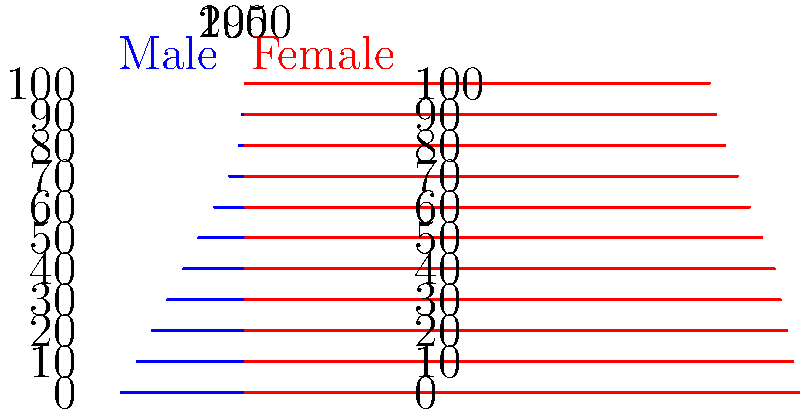Based on the population pyramids shown for 1950 and 2000, which demographic trend is most evident, and how might this impact the social and economic aspects discussed in the historian's book? To answer this question, let's analyze the population pyramids step-by-step:

1. Shape comparison:
   - 1950 pyramid: Wide base, narrow top (triangular shape)
   - 2000 pyramid: More rectangular shape, with a slightly narrower base

2. Age distribution:
   - 1950: Larger proportion of younger population (wider base)
   - 2000: More evenly distributed across age groups

3. Elderly population:
   - 1950: Very small proportion at the top of the pyramid
   - 2000: Larger proportion at the top, indicating increased longevity

4. Working-age population:
   - 1950: Smaller proportion in the middle
   - 2000: Larger proportion in the middle-age groups

5. Main trend: Aging population
   The most evident demographic trend is the aging of the population, as seen by the shift from a triangular shape to a more rectangular one.

6. Potential impacts discussed in the book:
   a. Social aspects:
      - Increased demand for healthcare and elderly care services
      - Changes in family structures and intergenerational relationships
      - Potential shifts in social norms and values

   b. Economic aspects:
      - Pressure on pension systems and social security
      - Changes in the labor force composition
      - Potential impact on economic growth and productivity
      - Shifts in consumer markets and product demands

   c. Policy implications:
      - Need for healthcare reform
      - Retirement age adjustments
      - Immigration policies to address workforce needs

The historian's book likely explores these implications in depth, analyzing how societies adapt to this demographic shift and its long-term consequences on various aspects of society and the economy.
Answer: Population aging, impacting healthcare, economy, and social structures 